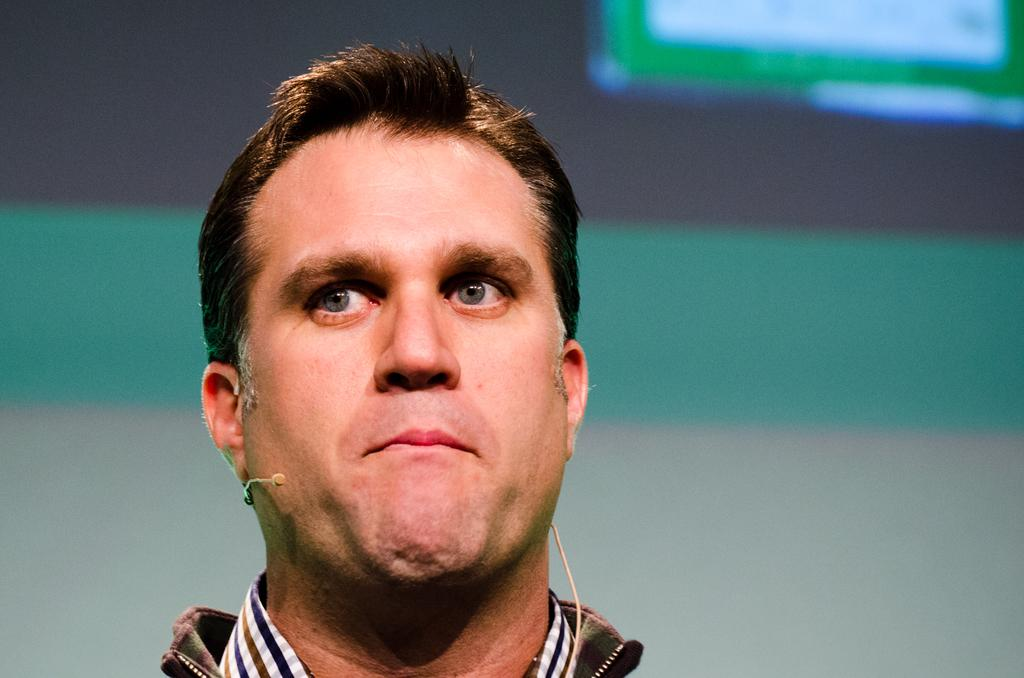What is the main subject in the foreground of the image? There is a person in the foreground of the image. What is the person wearing? The person is wearing a dress. What object is the person holding? The person is holding a microphone. What can be seen in the background of the image? There is a screen in the background of the image. Can you see any chickens in the image? There are no chickens present in the image. What type of gun is the person holding in the image? There is no gun present in the image; the person is holding a microphone. 